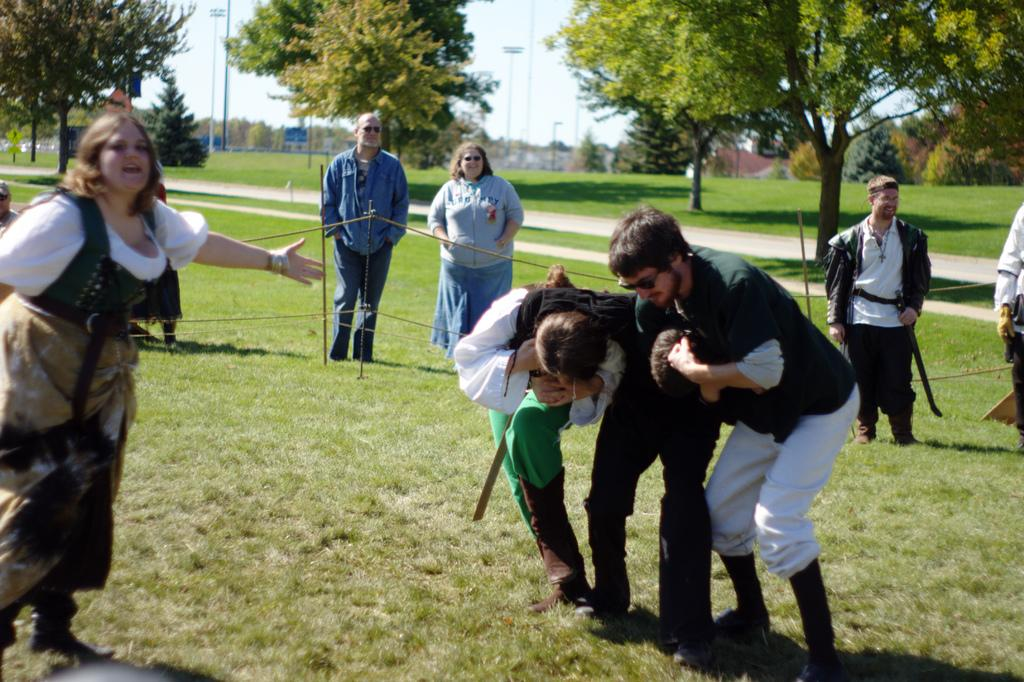What can be seen in the image? There are people standing in the image, along with grass, trees, a pathway, and poles in the background. What type of vegetation is present in the image? There are trees with branches and leaves in the image. What might the people be standing on? The presence of grass suggests that the people are standing on a grassy area. What can be seen in the distance in the image? Poles are visible in the background of the image. What type of sea creature can be seen rubbing its hands together in the image? There is no sea creature or any indication of rubbing hands in the image. 